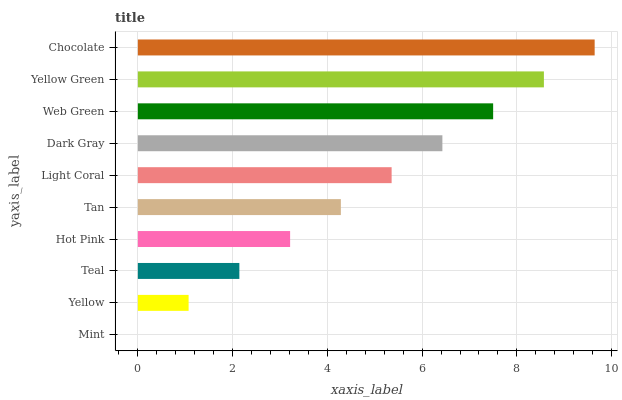Is Mint the minimum?
Answer yes or no. Yes. Is Chocolate the maximum?
Answer yes or no. Yes. Is Yellow the minimum?
Answer yes or no. No. Is Yellow the maximum?
Answer yes or no. No. Is Yellow greater than Mint?
Answer yes or no. Yes. Is Mint less than Yellow?
Answer yes or no. Yes. Is Mint greater than Yellow?
Answer yes or no. No. Is Yellow less than Mint?
Answer yes or no. No. Is Light Coral the high median?
Answer yes or no. Yes. Is Tan the low median?
Answer yes or no. Yes. Is Mint the high median?
Answer yes or no. No. Is Dark Gray the low median?
Answer yes or no. No. 